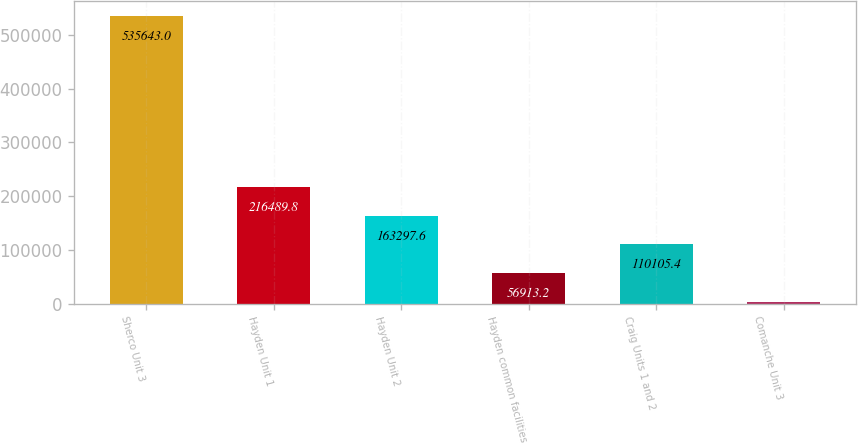Convert chart. <chart><loc_0><loc_0><loc_500><loc_500><bar_chart><fcel>Sherco Unit 3<fcel>Hayden Unit 1<fcel>Hayden Unit 2<fcel>Hayden common facilities<fcel>Craig Units 1 and 2<fcel>Comanche Unit 3<nl><fcel>535643<fcel>216490<fcel>163298<fcel>56913.2<fcel>110105<fcel>3721<nl></chart> 